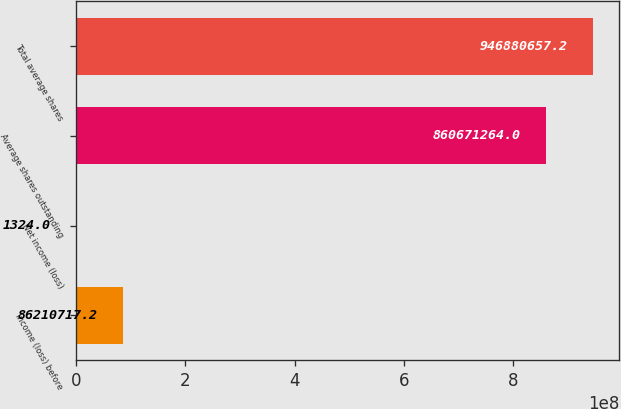<chart> <loc_0><loc_0><loc_500><loc_500><bar_chart><fcel>Income (loss) before<fcel>Net income (loss)<fcel>Average shares outstanding<fcel>Total average shares<nl><fcel>8.62107e+07<fcel>1324<fcel>8.60671e+08<fcel>9.46881e+08<nl></chart> 